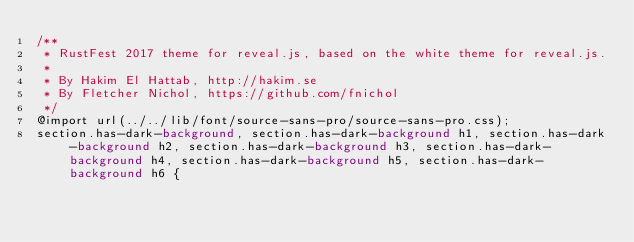Convert code to text. <code><loc_0><loc_0><loc_500><loc_500><_CSS_>/**
 * RustFest 2017 theme for reveal.js, based on the white theme for reveal.js.
 *
 * By Hakim El Hattab, http://hakim.se
 * By Fletcher Nichol, https://github.com/fnichol
 */
@import url(../../lib/font/source-sans-pro/source-sans-pro.css);
section.has-dark-background, section.has-dark-background h1, section.has-dark-background h2, section.has-dark-background h3, section.has-dark-background h4, section.has-dark-background h5, section.has-dark-background h6 {</code> 